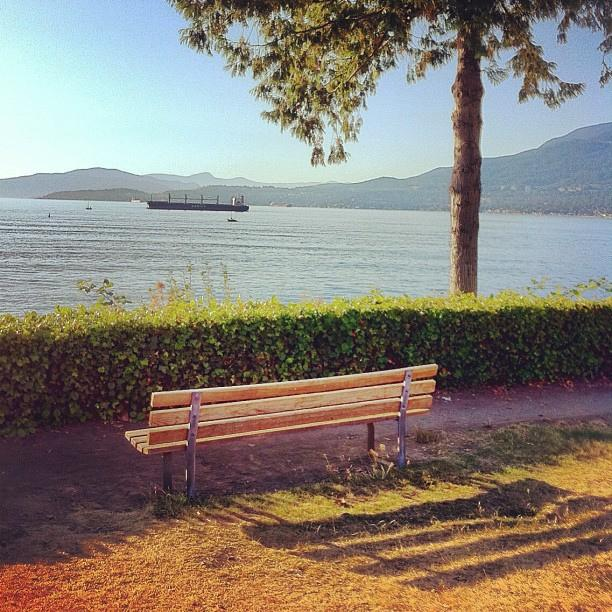What is casted on the ground behind the bench? Please explain your reasoning. shadow. It is sunny. the bench is blocking some of the sunlight, so there are dark areas on the ground. 